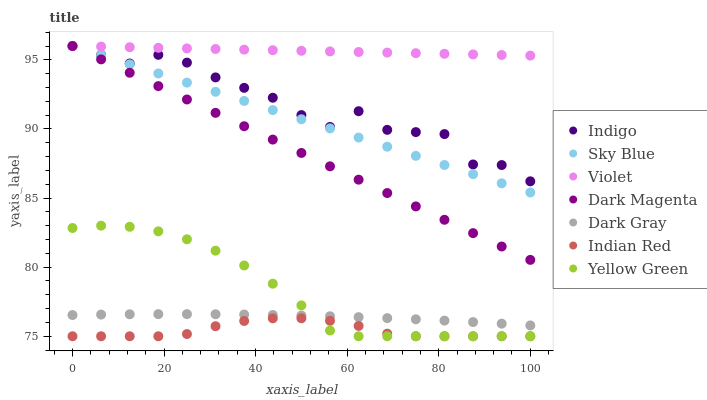Does Indian Red have the minimum area under the curve?
Answer yes or no. Yes. Does Violet have the maximum area under the curve?
Answer yes or no. Yes. Does Dark Magenta have the minimum area under the curve?
Answer yes or no. No. Does Dark Magenta have the maximum area under the curve?
Answer yes or no. No. Is Dark Magenta the smoothest?
Answer yes or no. Yes. Is Indigo the roughest?
Answer yes or no. Yes. Is Dark Gray the smoothest?
Answer yes or no. No. Is Dark Gray the roughest?
Answer yes or no. No. Does Indian Red have the lowest value?
Answer yes or no. Yes. Does Dark Magenta have the lowest value?
Answer yes or no. No. Does Sky Blue have the highest value?
Answer yes or no. Yes. Does Dark Gray have the highest value?
Answer yes or no. No. Is Dark Gray less than Sky Blue?
Answer yes or no. Yes. Is Dark Magenta greater than Yellow Green?
Answer yes or no. Yes. Does Indigo intersect Dark Magenta?
Answer yes or no. Yes. Is Indigo less than Dark Magenta?
Answer yes or no. No. Is Indigo greater than Dark Magenta?
Answer yes or no. No. Does Dark Gray intersect Sky Blue?
Answer yes or no. No. 